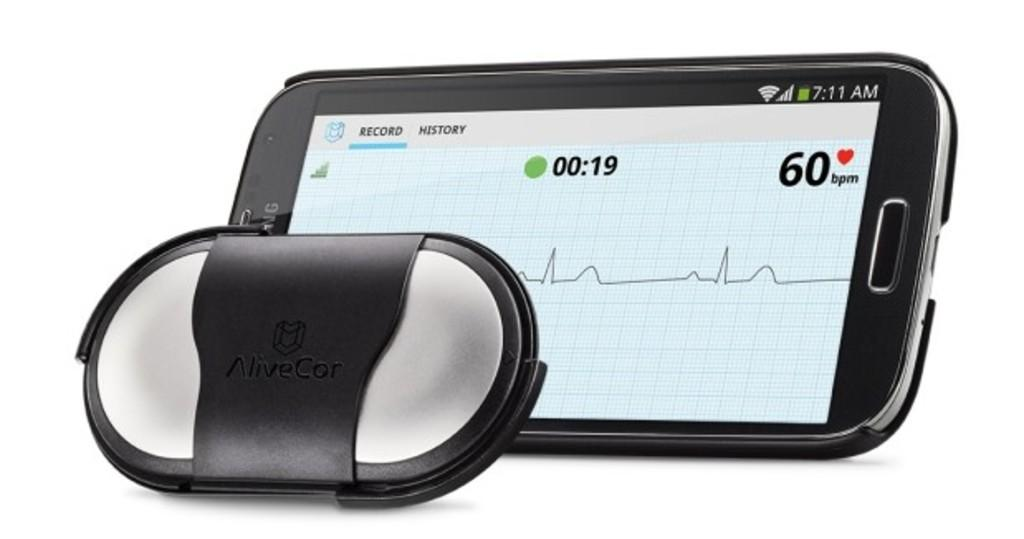<image>
Render a clear and concise summary of the photo. A cellphone has the word Record shown on it. 